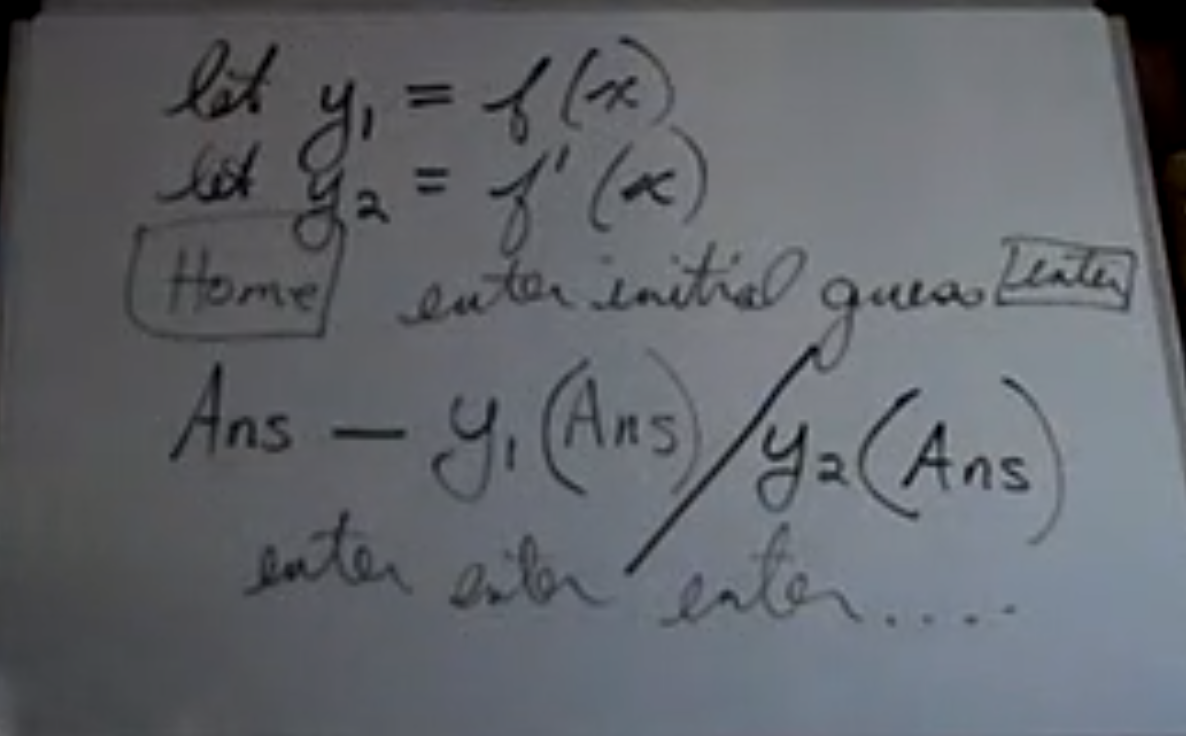What does this say?
 The image contains handwritten mathematical expressions and notes. It says:

Let y1 = f(x)
Let y2 = f'(x)

[There's a box drawn around the word "Home" with an arrow pointing to it from the expression for y2, which might indicate that it's a note or comment related to the problem at hand.]

enter initial guess [The word "guess" seems to be corrected or emphasized.]

Ans - y1(Ans)/y2(Ans)

enter enter enter ...

The expression seems to be related to an iterative method to find the roots of a function, where "Ans" represents the current approximation of the root, "y1" represents the function itself, and "y2" represents the derivative of the function. The "enter initial guess" note suggests that this is a step in a computational or algorithmic process where an initial guess is needed to start the iterations. The final line with "enter enter enter ..." may suggest repeating the process with the new approximation until the desired level of accuracy is achieved. This resembles the Newton-Raphson method for finding successively better approximations to the roots (or zeroes) of a real-valued function. 